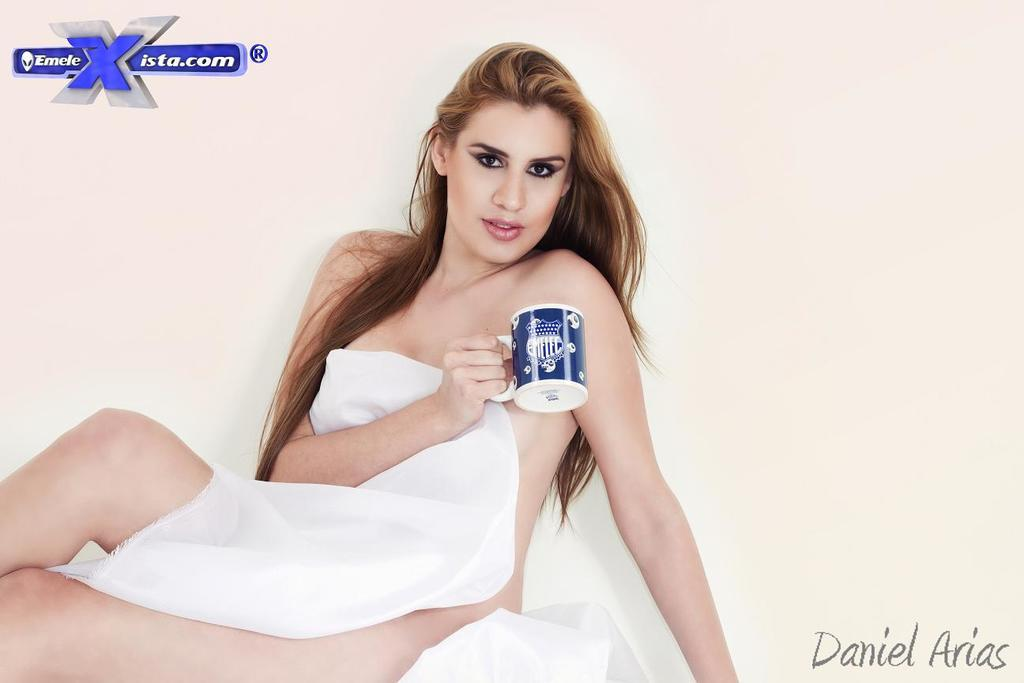Who is present in the image? There is a woman in the image. What is the woman wearing? The woman is wearing a white cloth. What is the woman holding in the image? The woman is holding a cup. Can you describe the cup's appearance? The cup is white and blue in color. What is the color of the background in the image? The background is white in color. What type of scent can be detected from the ink in the image? There is no ink present in the image, so it is not possible to detect any scent from it. 